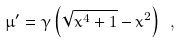Convert formula to latex. <formula><loc_0><loc_0><loc_500><loc_500>\mu ^ { \prime } = \gamma \left ( \sqrt { x ^ { 4 } + 1 } - x ^ { 2 } \right ) \ ,</formula> 